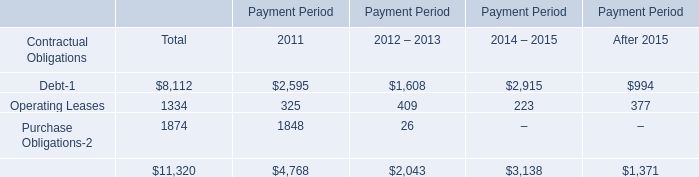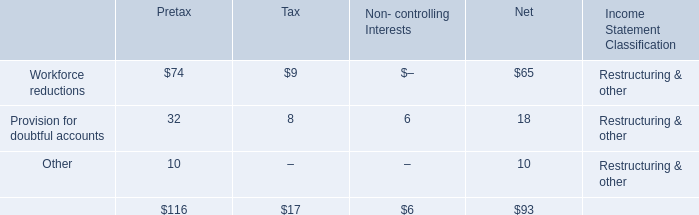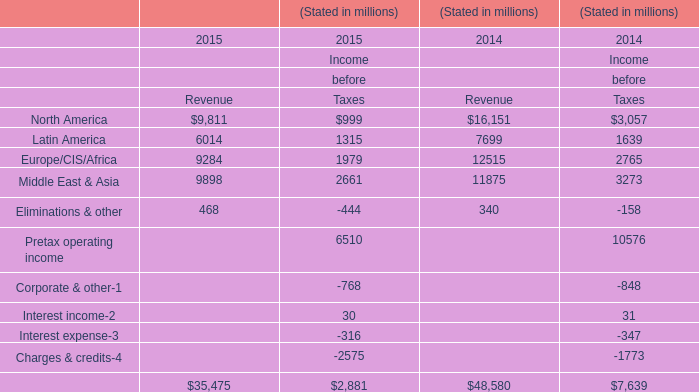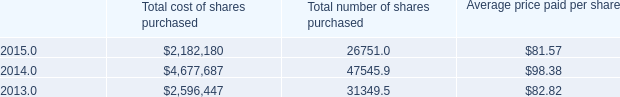what was the percent of the share under this new share repurchase program as of december 312015 
Computations: (8.6 / 10)
Answer: 0.86. 